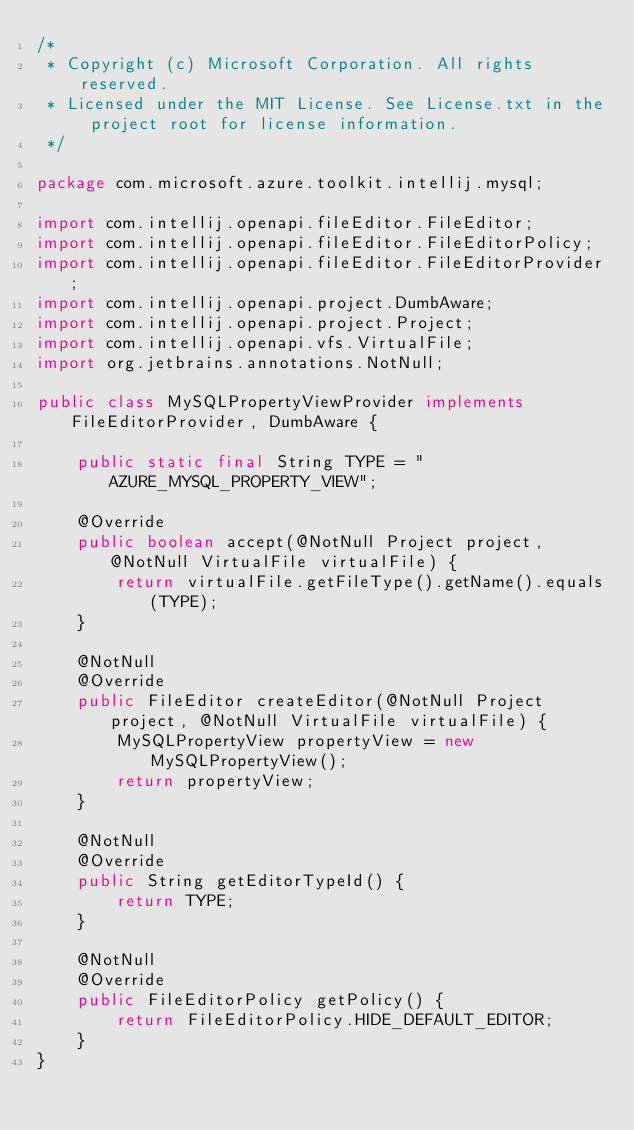Convert code to text. <code><loc_0><loc_0><loc_500><loc_500><_Java_>/*
 * Copyright (c) Microsoft Corporation. All rights reserved.
 * Licensed under the MIT License. See License.txt in the project root for license information.
 */

package com.microsoft.azure.toolkit.intellij.mysql;

import com.intellij.openapi.fileEditor.FileEditor;
import com.intellij.openapi.fileEditor.FileEditorPolicy;
import com.intellij.openapi.fileEditor.FileEditorProvider;
import com.intellij.openapi.project.DumbAware;
import com.intellij.openapi.project.Project;
import com.intellij.openapi.vfs.VirtualFile;
import org.jetbrains.annotations.NotNull;

public class MySQLPropertyViewProvider implements FileEditorProvider, DumbAware {

    public static final String TYPE = "AZURE_MYSQL_PROPERTY_VIEW";

    @Override
    public boolean accept(@NotNull Project project, @NotNull VirtualFile virtualFile) {
        return virtualFile.getFileType().getName().equals(TYPE);
    }

    @NotNull
    @Override
    public FileEditor createEditor(@NotNull Project project, @NotNull VirtualFile virtualFile) {
        MySQLPropertyView propertyView = new MySQLPropertyView();
        return propertyView;
    }

    @NotNull
    @Override
    public String getEditorTypeId() {
        return TYPE;
    }

    @NotNull
    @Override
    public FileEditorPolicy getPolicy() {
        return FileEditorPolicy.HIDE_DEFAULT_EDITOR;
    }
}
</code> 